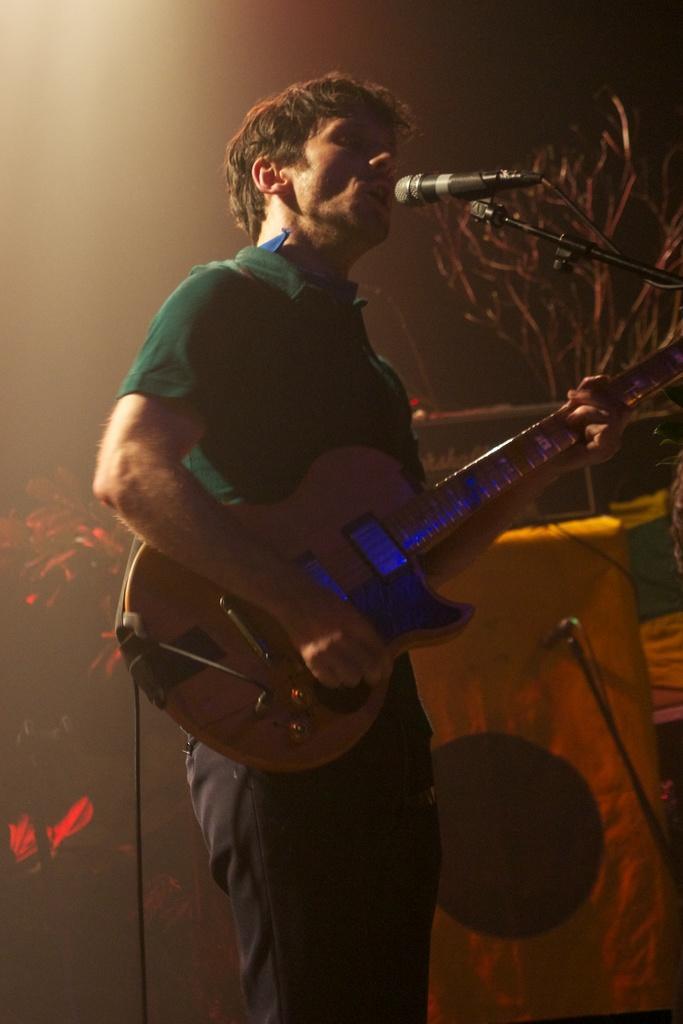Describe this image in one or two sentences. A man is standing also playing the guitar. Singing on the microphone. 